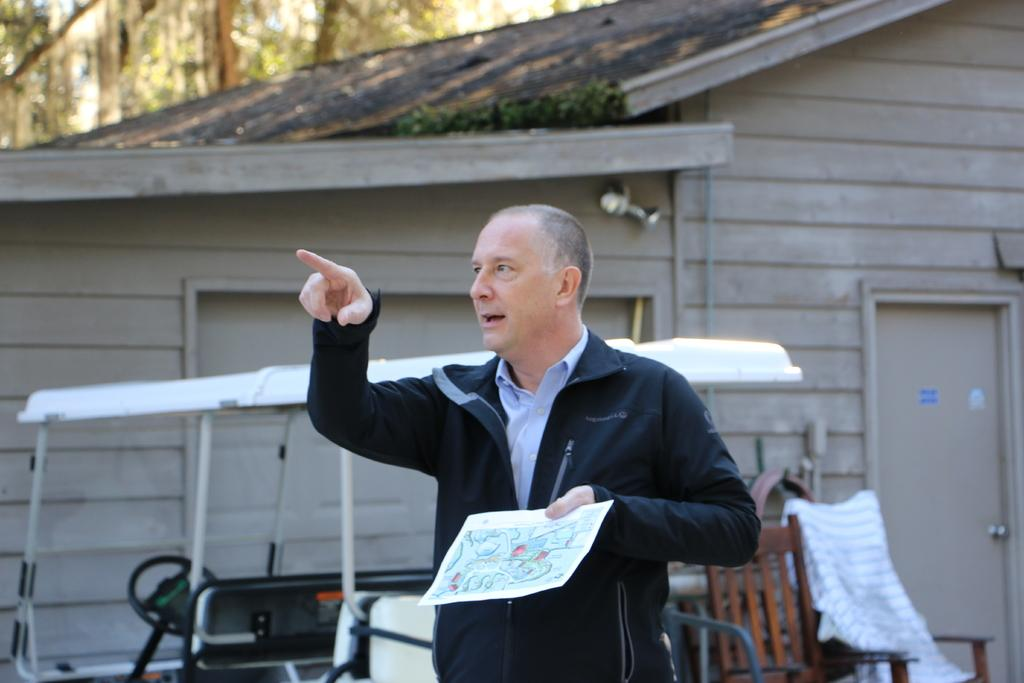What is the person in the image holding? The person is holding a paper. What else can be seen in the image besides the person? There is a vehicle, chairs, a house, a shutter, a door, and trees in the background of the image. Can you describe the vehicle in the image? The facts provided do not give specific details about the vehicle. What type of structure is the house in the image? The facts provided do not give specific details about the house. What word is written on the level in the image? There is no level or word present in the image. 